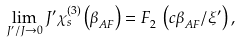Convert formula to latex. <formula><loc_0><loc_0><loc_500><loc_500>\lim _ { J ^ { \prime } / J \to 0 } J ^ { \prime } \chi ^ { ( 3 ) } _ { s } \left ( \beta ^ { \ } _ { A F } \right ) = F ^ { \ } _ { 2 } \left ( c \beta ^ { \ } _ { A F } / \xi ^ { \prime } \right ) ,</formula> 